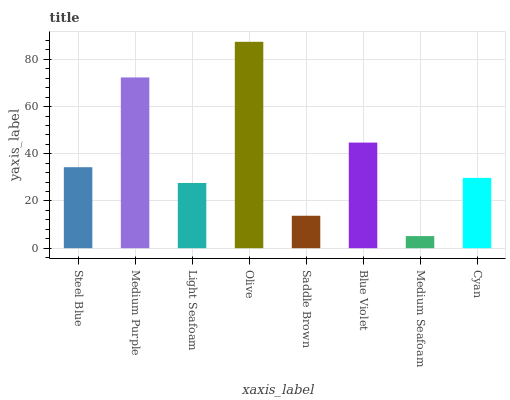Is Medium Purple the minimum?
Answer yes or no. No. Is Medium Purple the maximum?
Answer yes or no. No. Is Medium Purple greater than Steel Blue?
Answer yes or no. Yes. Is Steel Blue less than Medium Purple?
Answer yes or no. Yes. Is Steel Blue greater than Medium Purple?
Answer yes or no. No. Is Medium Purple less than Steel Blue?
Answer yes or no. No. Is Steel Blue the high median?
Answer yes or no. Yes. Is Cyan the low median?
Answer yes or no. Yes. Is Cyan the high median?
Answer yes or no. No. Is Blue Violet the low median?
Answer yes or no. No. 